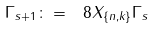Convert formula to latex. <formula><loc_0><loc_0><loc_500><loc_500>\Gamma _ { s + 1 } \colon = \ 8 X _ { \{ n , k \} } \Gamma _ { s }</formula> 